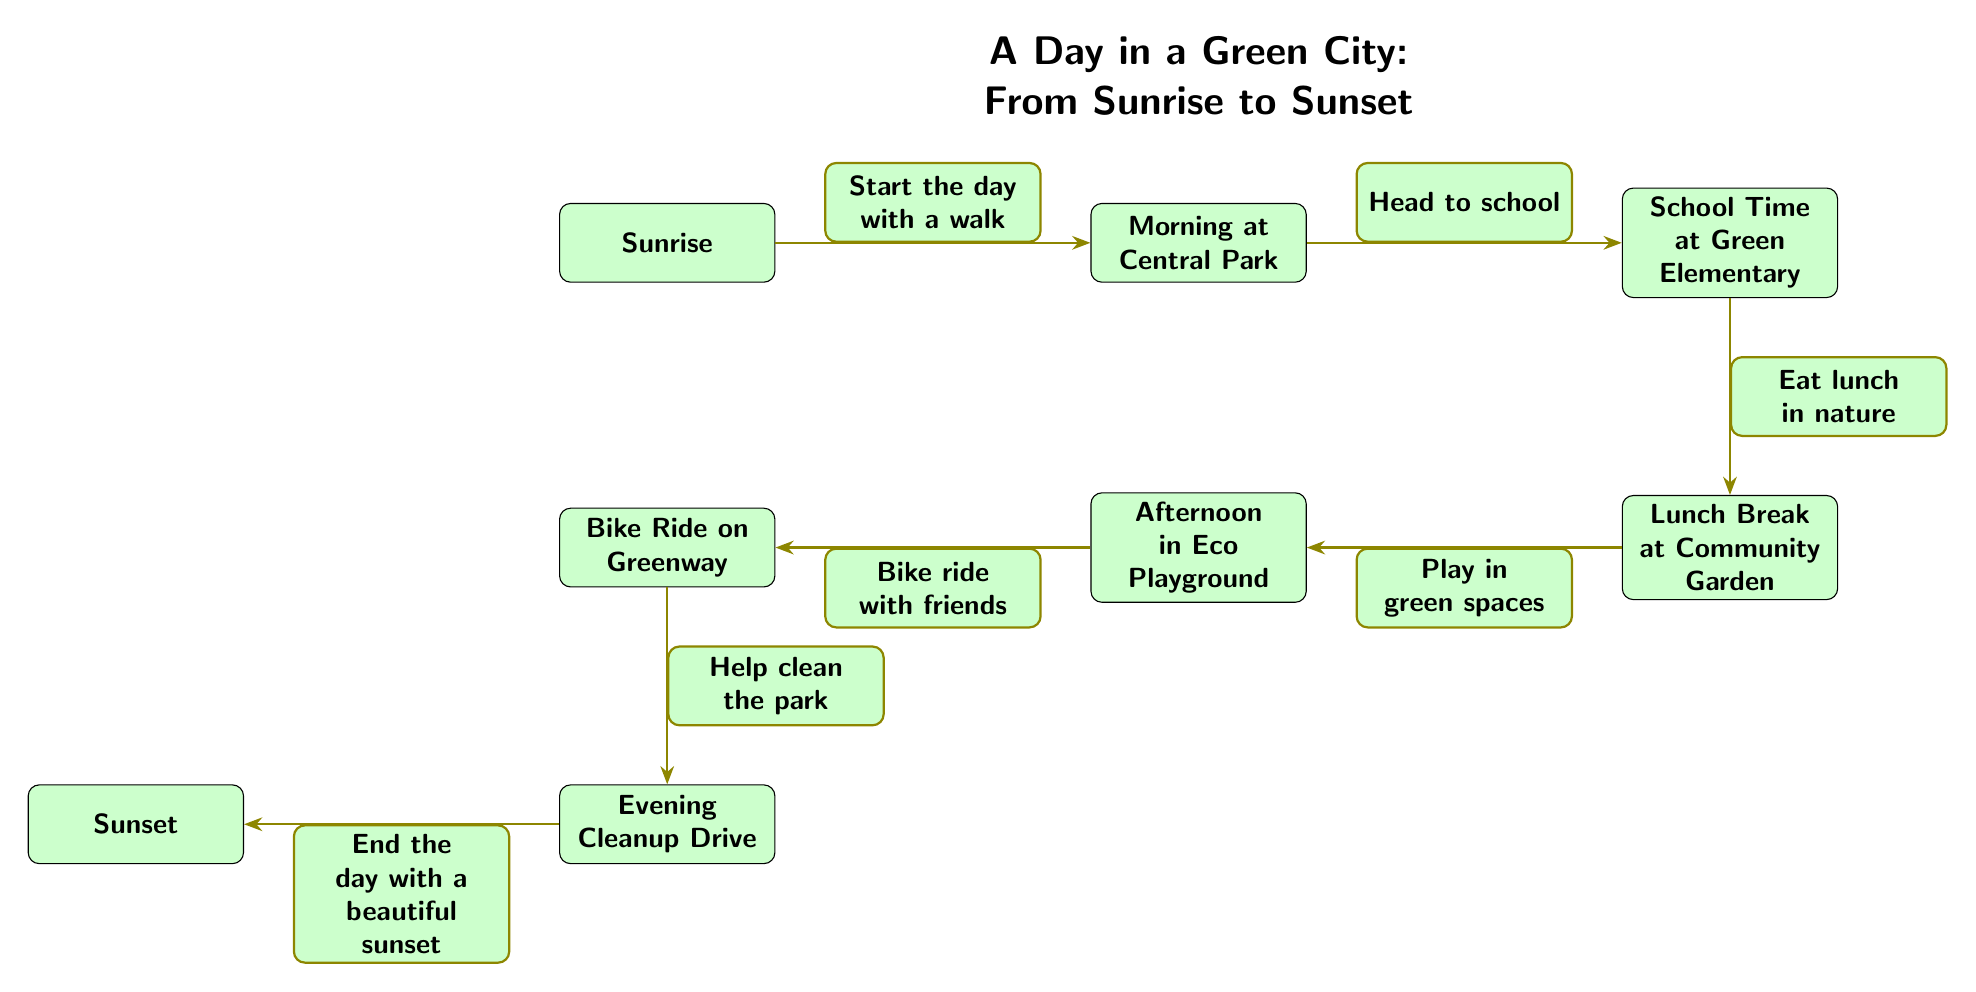What is the first activity of the day? The diagram starts with the node labeled "Sunrise," which indicates the first activity. The arrow leads to the "Morning at Central Park" node, but it is clear that "Sunrise" is where the day begins.
Answer: Sunrise How many activities are shown in the diagram? By counting the nodes, we see there are a total of seven activities: Sunrise, Morning at Central Park, School Time at Green Elementary, Lunch Break at Community Garden, Afternoon in Eco Playground, Bike Ride on Greenway, Evening Cleanup Drive, and Sunset.
Answer: 7 What does the "School Time at Green Elementary" lead to? The diagram shows an arrow leading from the "School Time at Green Elementary" node to the "Lunch Break at Community Garden" node. This indicates that after school time, the next activity is lunch break.
Answer: Lunch Break at Community Garden What activity occurs just before the "Sunset"? The diagram indicates that "Evening Cleanup Drive" is the activity that occurs right before "Sunset" as shown by the arrow leading to it.
Answer: Evening Cleanup Drive Which activity is associated with playing? The "Afternoon in Eco Playground" is specifically labeled with the activity of playing in green spaces as it leads to the bike ride with friends.
Answer: Afternoon in Eco Playground What do people do during their lunch break? The diagram connects "Lunch Break at Community Garden" with the note "Eat lunch in nature," indicating that during lunch break, people eat in a natural setting.
Answer: Eat lunch in nature What is the final description of the day? The last node shows "End the day with a beautiful sunset," which describes the conclusion of the day's activities in the diagram.
Answer: End the day with a beautiful sunset What is the transition from "Bike Ride on Greenway"? The diagram shows an arrow leading from "Bike Ride on Greenway," with the description "Help clean the park," indicating the next activity that follows the bike ride.
Answer: Help clean the park 